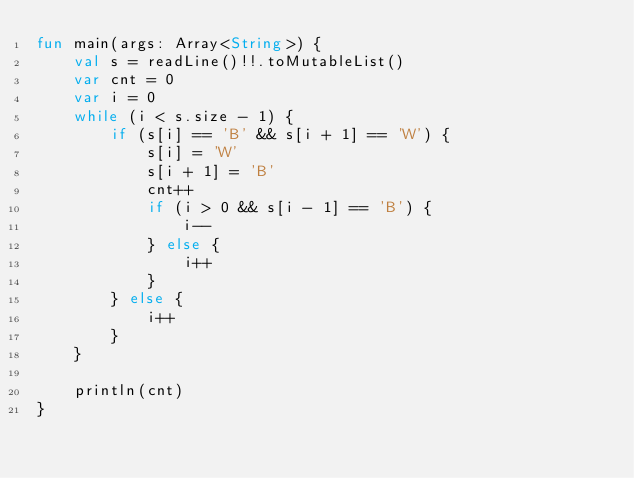<code> <loc_0><loc_0><loc_500><loc_500><_Kotlin_>fun main(args: Array<String>) {
    val s = readLine()!!.toMutableList()
    var cnt = 0
    var i = 0
    while (i < s.size - 1) {
        if (s[i] == 'B' && s[i + 1] == 'W') {
            s[i] = 'W'
            s[i + 1] = 'B'
            cnt++
            if (i > 0 && s[i - 1] == 'B') {
                i--
            } else {
                i++
            }
        } else {
            i++
        }
    }

    println(cnt)
}</code> 